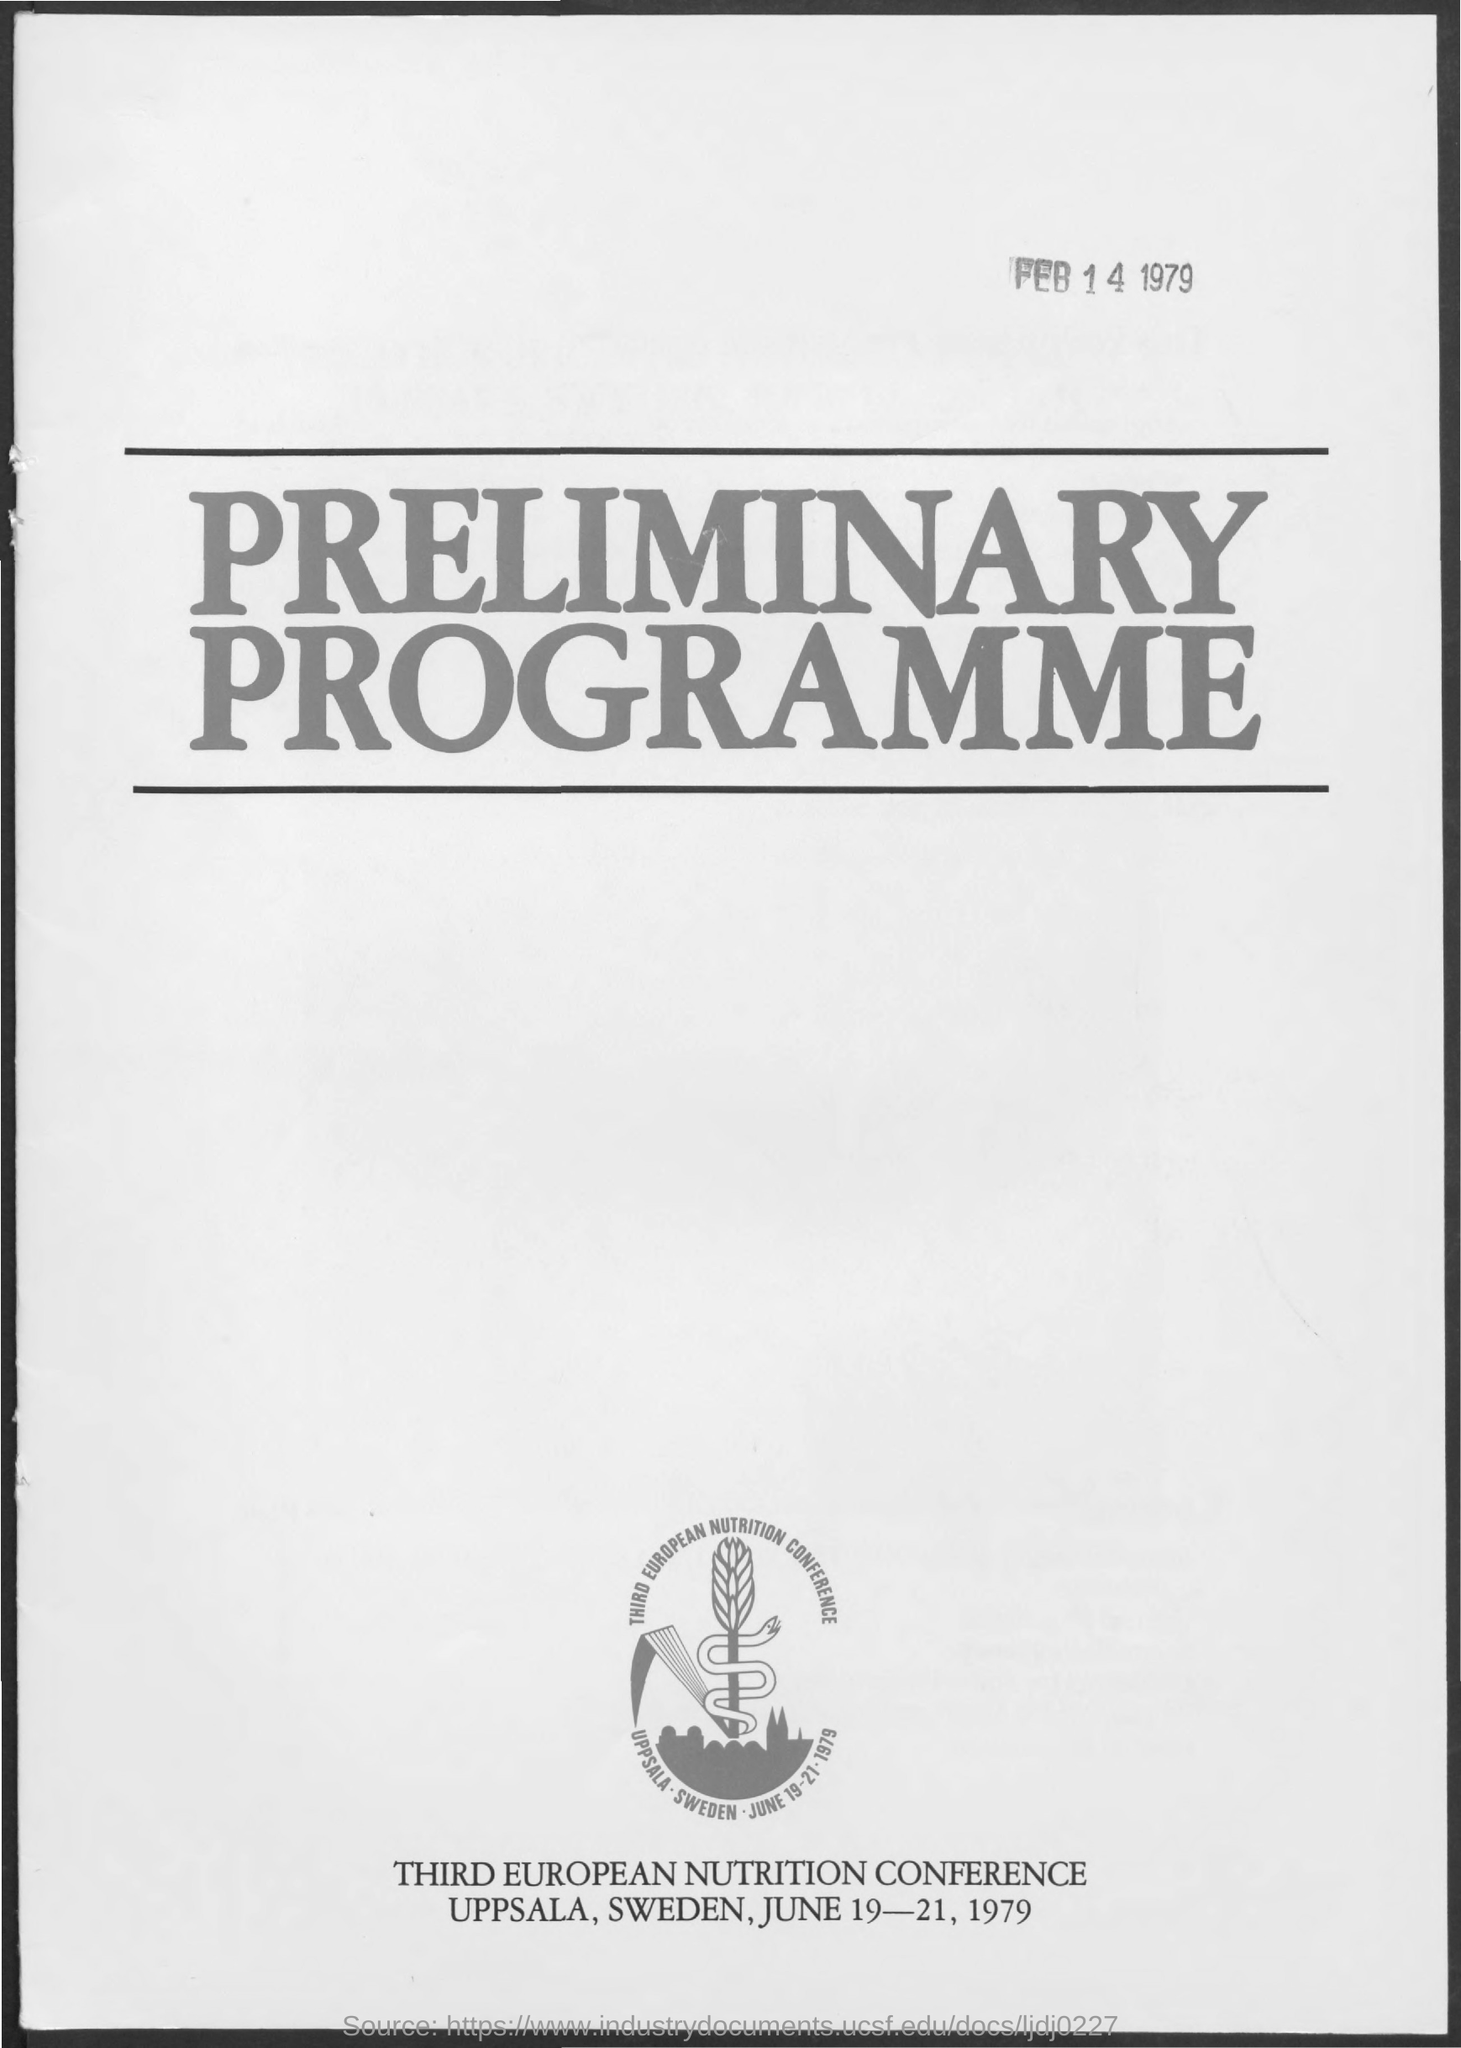When is the Third European Nutrition Conference?
Offer a very short reply. June 19-21, 1979. Where is the Third European Nutrition Conference?
Make the answer very short. Uppsala, sweden. What is the Title of the document?
Your answer should be compact. Preliminary programme. 